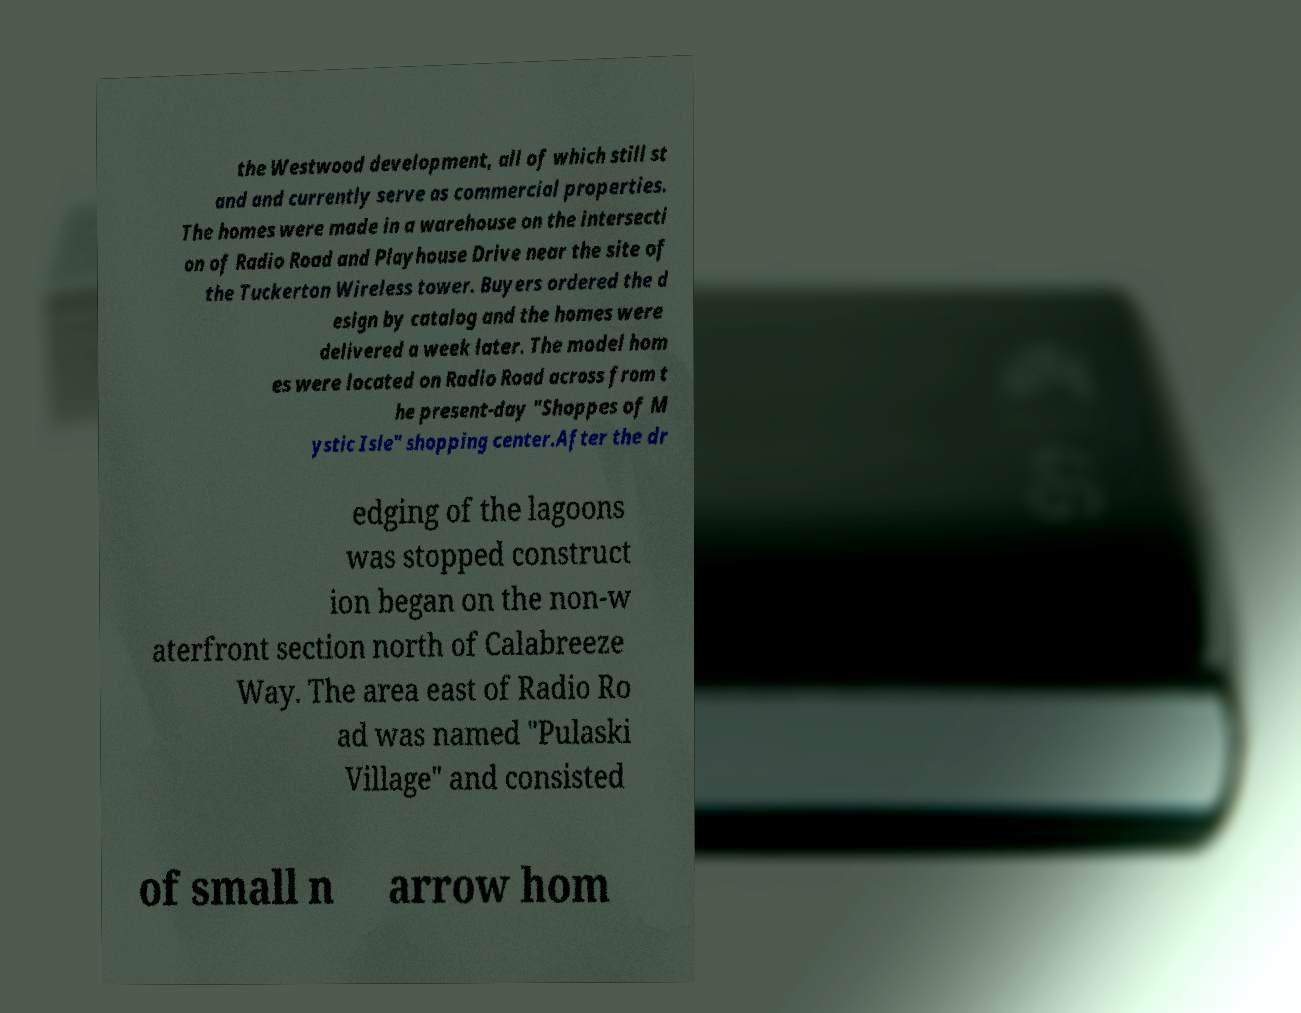For documentation purposes, I need the text within this image transcribed. Could you provide that? the Westwood development, all of which still st and and currently serve as commercial properties. The homes were made in a warehouse on the intersecti on of Radio Road and Playhouse Drive near the site of the Tuckerton Wireless tower. Buyers ordered the d esign by catalog and the homes were delivered a week later. The model hom es were located on Radio Road across from t he present-day "Shoppes of M ystic Isle" shopping center.After the dr edging of the lagoons was stopped construct ion began on the non-w aterfront section north of Calabreeze Way. The area east of Radio Ro ad was named "Pulaski Village" and consisted of small n arrow hom 